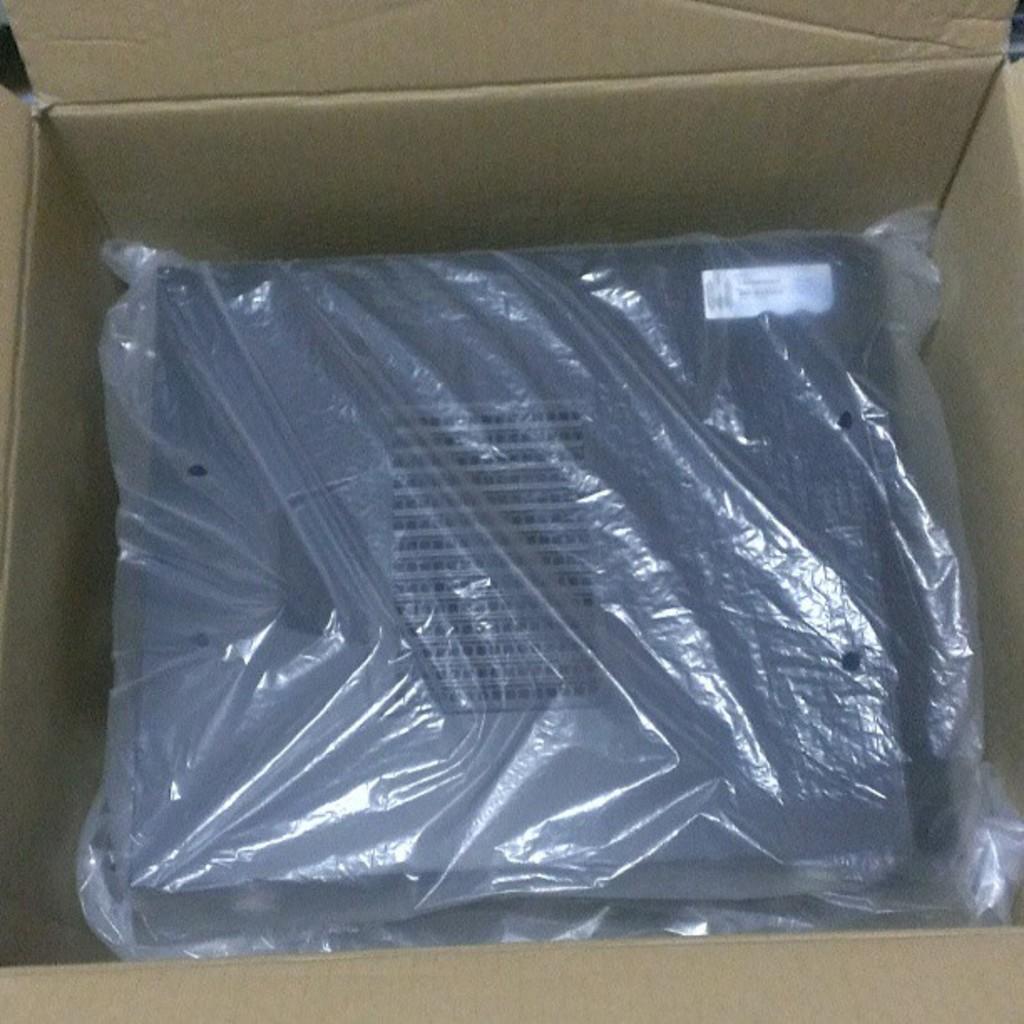Describe this image in one or two sentences. In the image inside the cardboard box there is an object covered with a cover. 